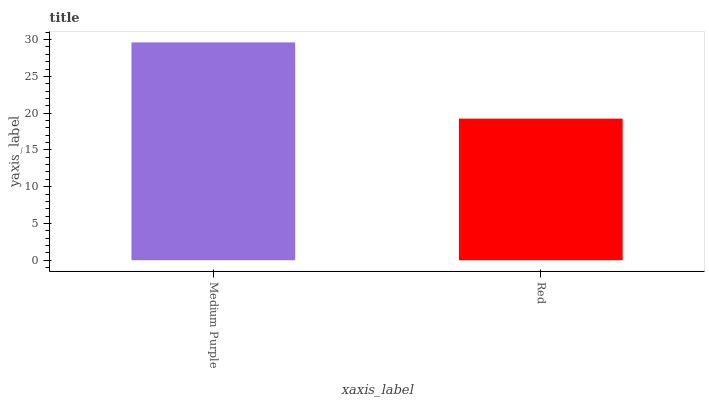Is Red the minimum?
Answer yes or no. Yes. Is Medium Purple the maximum?
Answer yes or no. Yes. Is Red the maximum?
Answer yes or no. No. Is Medium Purple greater than Red?
Answer yes or no. Yes. Is Red less than Medium Purple?
Answer yes or no. Yes. Is Red greater than Medium Purple?
Answer yes or no. No. Is Medium Purple less than Red?
Answer yes or no. No. Is Medium Purple the high median?
Answer yes or no. Yes. Is Red the low median?
Answer yes or no. Yes. Is Red the high median?
Answer yes or no. No. Is Medium Purple the low median?
Answer yes or no. No. 